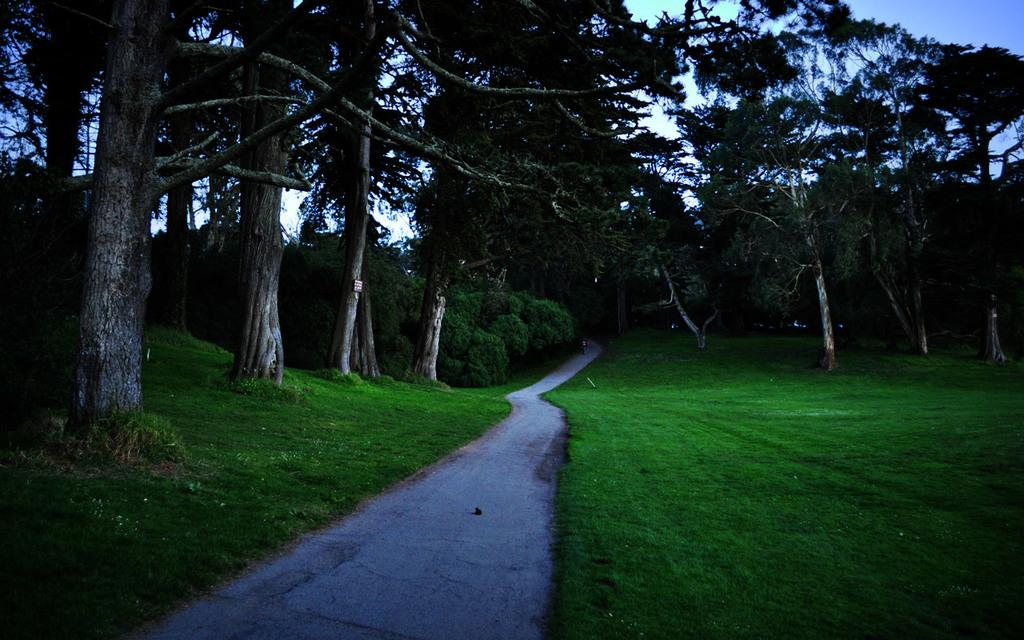What type of vegetation can be seen in the image? There are trees in the image. What else can be seen in the image besides trees? There is grass in the image. Where are the trees and grass located in relation to other elements in the image? The trees and grass are beside a road. What type of line can be seen on the skirt of the person walking in the image? There is no person or skirt present in the image; it features trees and grass beside a road. 